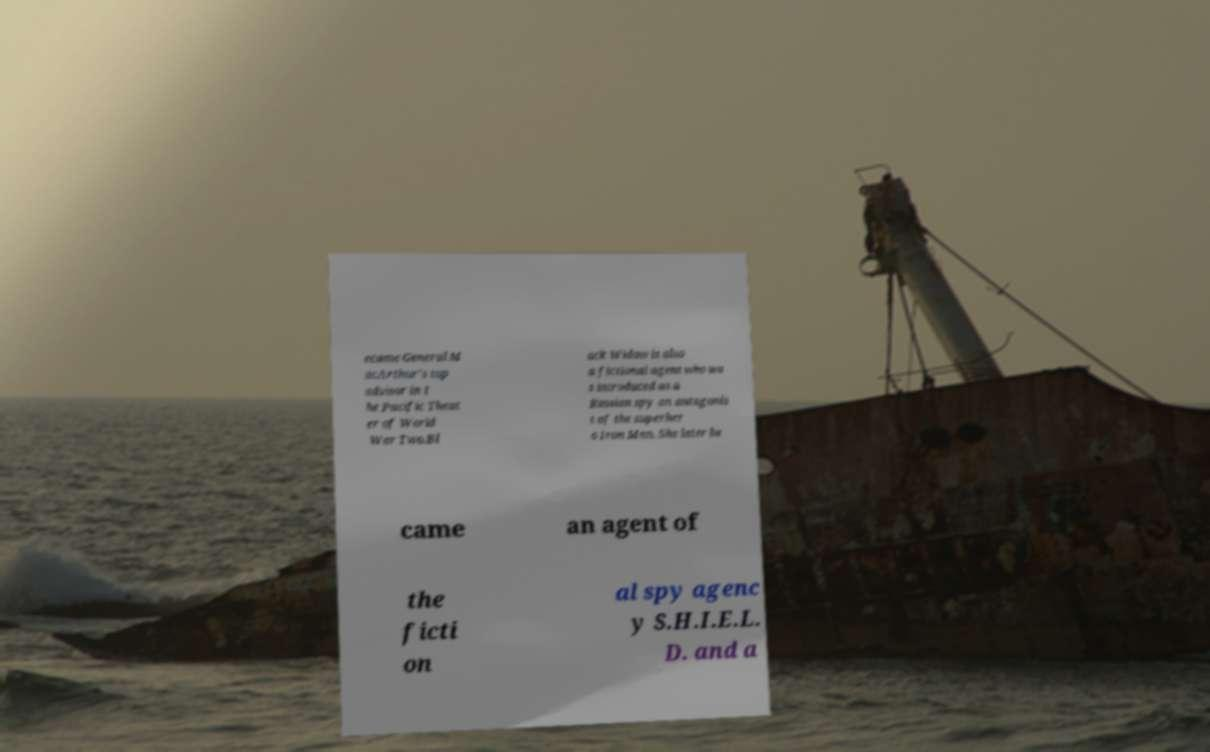Could you assist in decoding the text presented in this image and type it out clearly? ecame General M acArthur's top advisor in t he Pacific Theat er of World War Two.Bl ack Widow is also a fictional agent who wa s introduced as a Russian spy an antagonis t of the superher o Iron Man. She later be came an agent of the ficti on al spy agenc y S.H.I.E.L. D. and a 